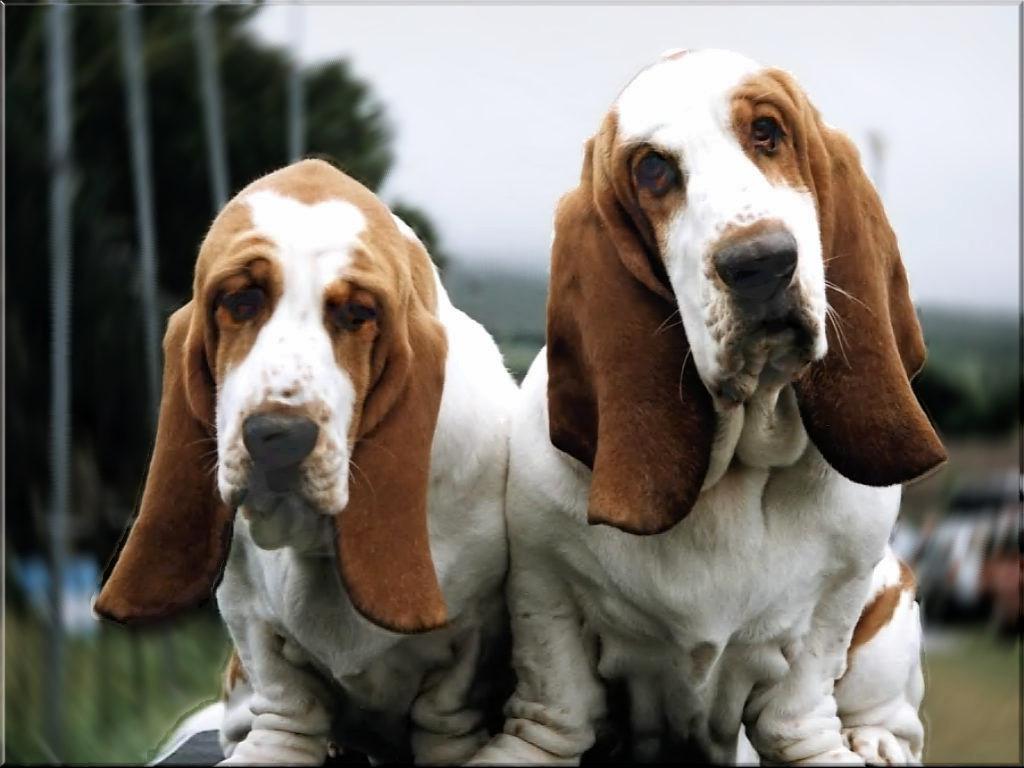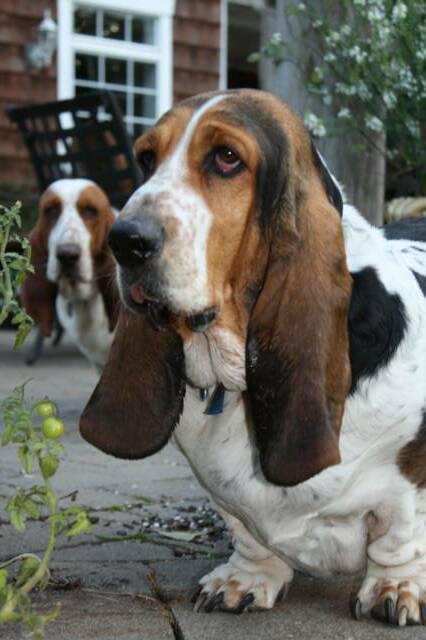The first image is the image on the left, the second image is the image on the right. Examine the images to the left and right. Is the description "In one image there is two basset hounds outside standing on a brick walkway." accurate? Answer yes or no. Yes. The first image is the image on the left, the second image is the image on the right. Evaluate the accuracy of this statement regarding the images: "There are at most two dogs.". Is it true? Answer yes or no. No. 